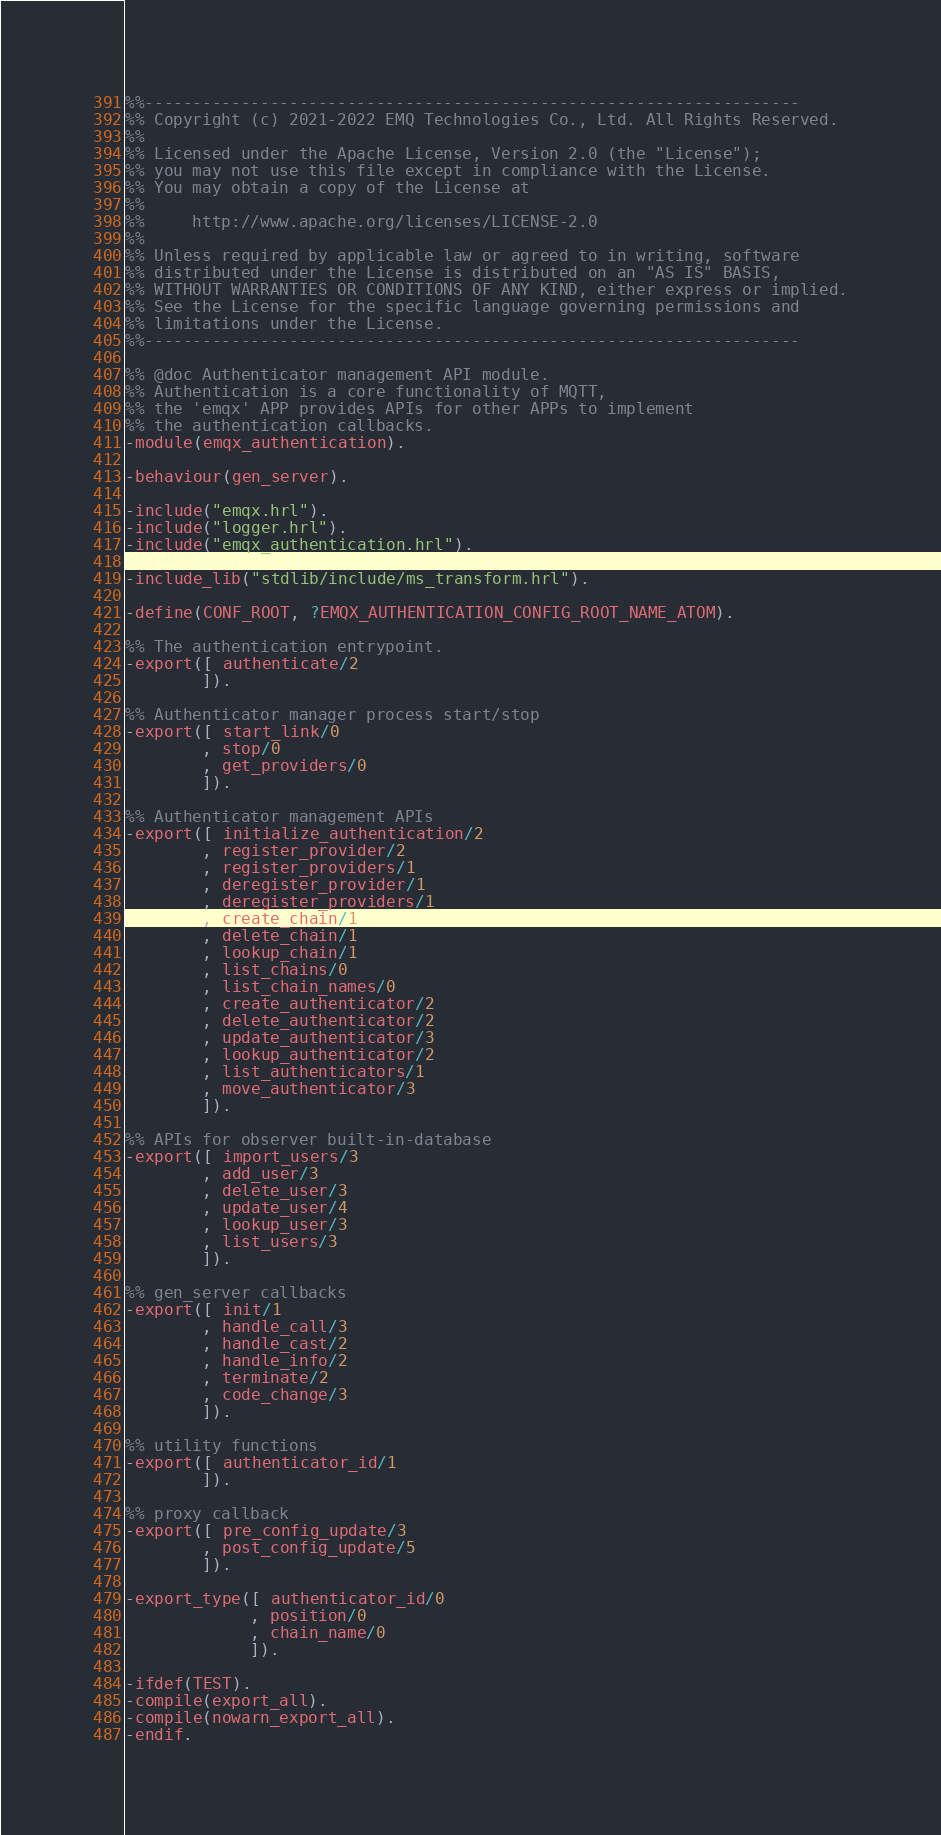<code> <loc_0><loc_0><loc_500><loc_500><_Erlang_>%%--------------------------------------------------------------------
%% Copyright (c) 2021-2022 EMQ Technologies Co., Ltd. All Rights Reserved.
%%
%% Licensed under the Apache License, Version 2.0 (the "License");
%% you may not use this file except in compliance with the License.
%% You may obtain a copy of the License at
%%
%%     http://www.apache.org/licenses/LICENSE-2.0
%%
%% Unless required by applicable law or agreed to in writing, software
%% distributed under the License is distributed on an "AS IS" BASIS,
%% WITHOUT WARRANTIES OR CONDITIONS OF ANY KIND, either express or implied.
%% See the License for the specific language governing permissions and
%% limitations under the License.
%%--------------------------------------------------------------------

%% @doc Authenticator management API module.
%% Authentication is a core functionality of MQTT,
%% the 'emqx' APP provides APIs for other APPs to implement
%% the authentication callbacks.
-module(emqx_authentication).

-behaviour(gen_server).

-include("emqx.hrl").
-include("logger.hrl").
-include("emqx_authentication.hrl").

-include_lib("stdlib/include/ms_transform.hrl").

-define(CONF_ROOT, ?EMQX_AUTHENTICATION_CONFIG_ROOT_NAME_ATOM).

%% The authentication entrypoint.
-export([ authenticate/2
        ]).

%% Authenticator manager process start/stop
-export([ start_link/0
        , stop/0
        , get_providers/0
        ]).

%% Authenticator management APIs
-export([ initialize_authentication/2
        , register_provider/2
        , register_providers/1
        , deregister_provider/1
        , deregister_providers/1
        , create_chain/1
        , delete_chain/1
        , lookup_chain/1
        , list_chains/0
        , list_chain_names/0
        , create_authenticator/2
        , delete_authenticator/2
        , update_authenticator/3
        , lookup_authenticator/2
        , list_authenticators/1
        , move_authenticator/3
        ]).

%% APIs for observer built-in-database
-export([ import_users/3
        , add_user/3
        , delete_user/3
        , update_user/4
        , lookup_user/3
        , list_users/3
        ]).

%% gen_server callbacks
-export([ init/1
        , handle_call/3
        , handle_cast/2
        , handle_info/2
        , terminate/2
        , code_change/3
        ]).

%% utility functions
-export([ authenticator_id/1
        ]).

%% proxy callback
-export([ pre_config_update/3
        , post_config_update/5
        ]).

-export_type([ authenticator_id/0
             , position/0
             , chain_name/0
             ]).

-ifdef(TEST).
-compile(export_all).
-compile(nowarn_export_all).
-endif.
</code> 